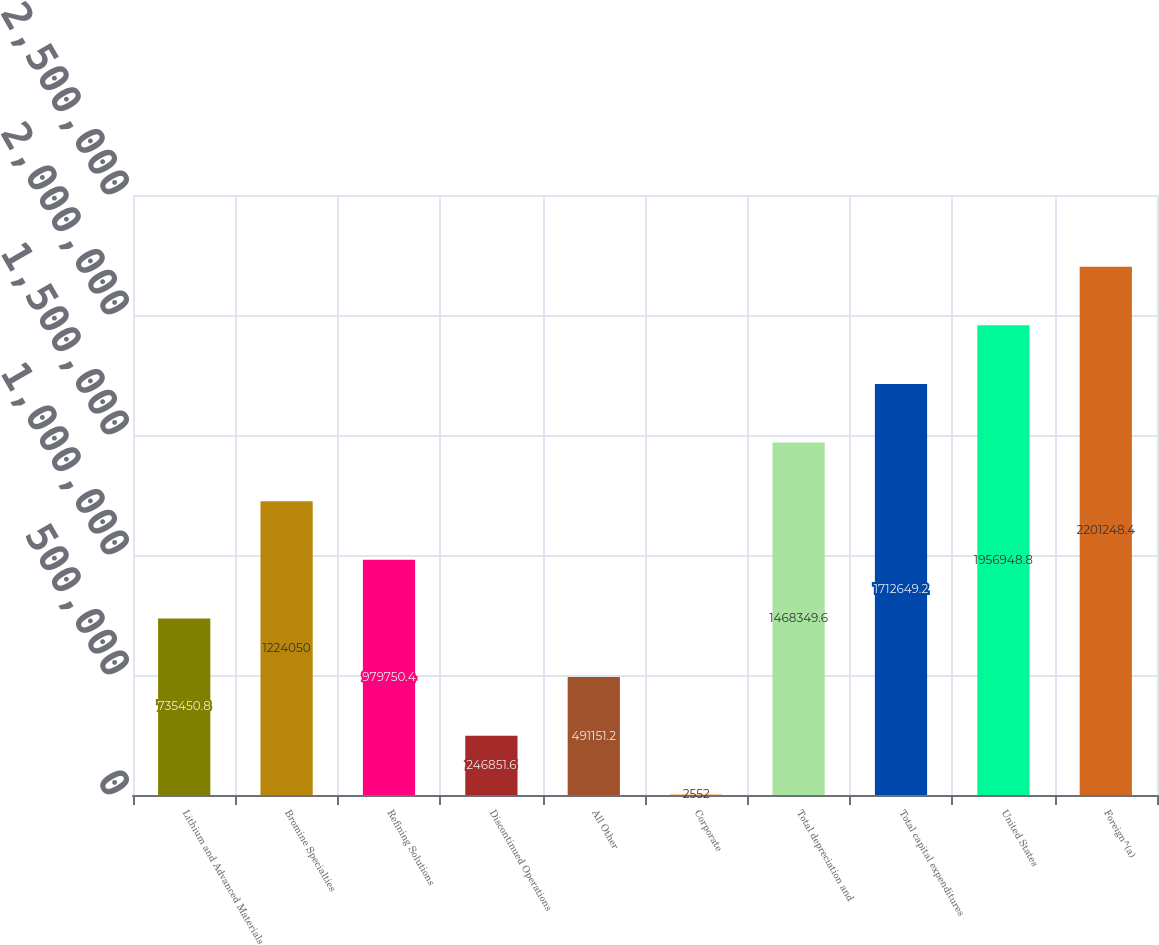Convert chart. <chart><loc_0><loc_0><loc_500><loc_500><bar_chart><fcel>Lithium and Advanced Materials<fcel>Bromine Specialties<fcel>Refining Solutions<fcel>Discontinued Operations<fcel>All Other<fcel>Corporate<fcel>Total depreciation and<fcel>Total capital expenditures<fcel>United States<fcel>Foreign^(a)<nl><fcel>735451<fcel>1.22405e+06<fcel>979750<fcel>246852<fcel>491151<fcel>2552<fcel>1.46835e+06<fcel>1.71265e+06<fcel>1.95695e+06<fcel>2.20125e+06<nl></chart> 